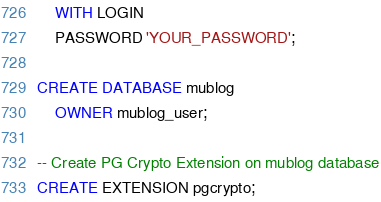Convert code to text. <code><loc_0><loc_0><loc_500><loc_500><_SQL_>    WITH LOGIN
    PASSWORD 'YOUR_PASSWORD';

CREATE DATABASE mublog
    OWNER mublog_user;

-- Create PG Crypto Extension on mublog database
CREATE EXTENSION pgcrypto;
</code> 